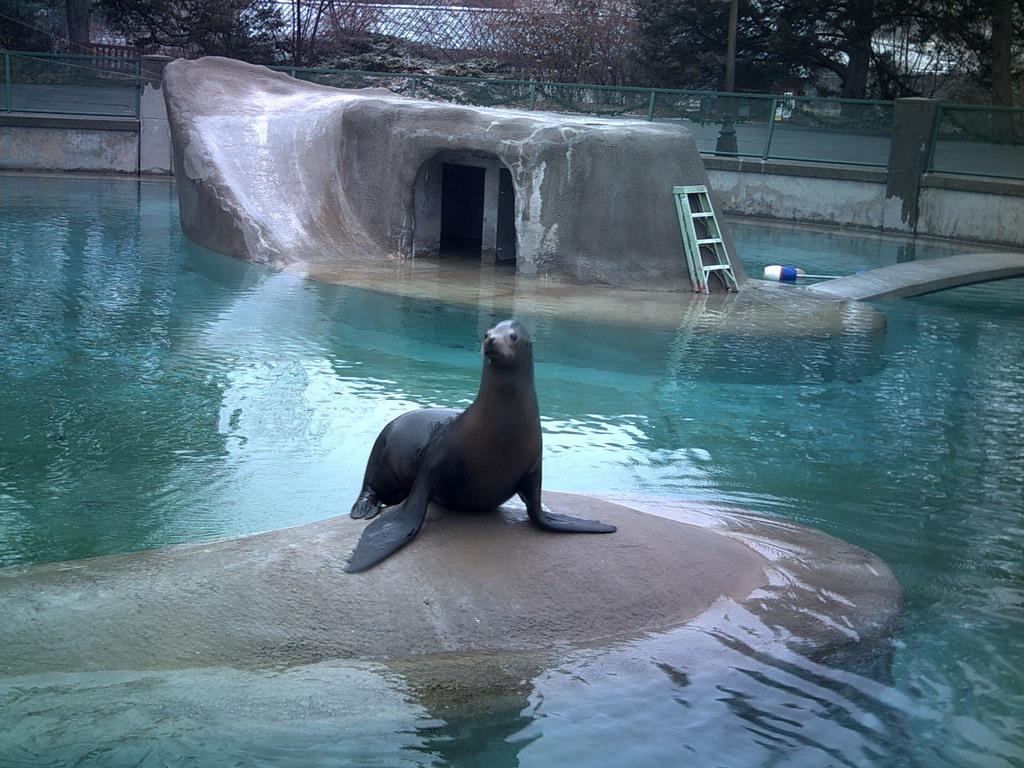Please provide a concise description of this image. In the background we can see the mesh, trees, a pole. In this picture we can see the cave, ladder and an object, water. We can see an animal called as seal on a surface. 